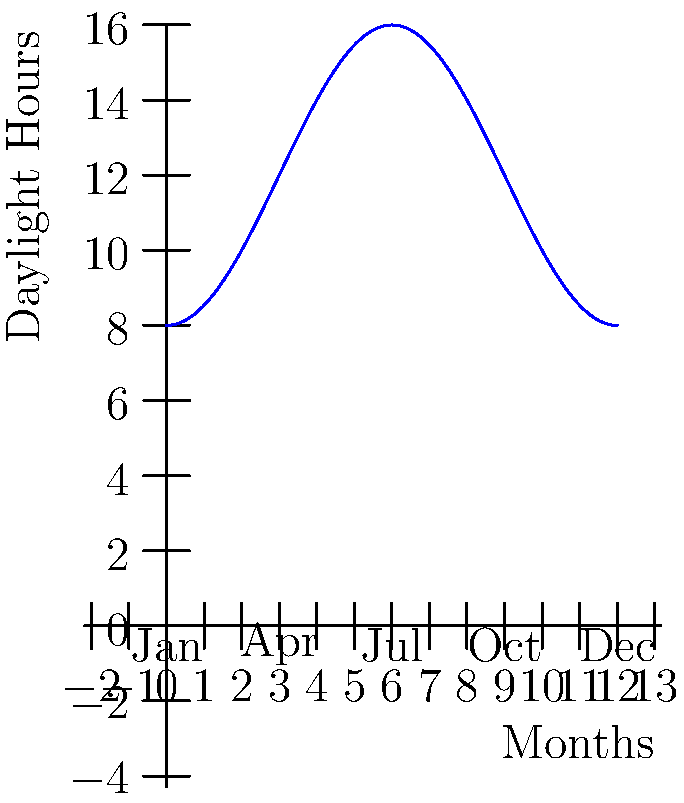The graph shows the average daylight hours throughout the year in Kuujjuaq, northern Quebec. During which month does the rate of change in daylight hours reach its maximum, and what is this maximum rate of change in hours per month? To find the month with the maximum rate of change in daylight hours and its value:

1. The rate of change is represented by the slope of the curve.
2. The steepest part of the curve occurs at the inflection points, where the curve changes from concave up to concave down or vice versa.
3. From the graph, we can see two inflection points: one between January and April, and another between September and December.
4. The steeper slope appears to be between September and December.
5. To calculate the rate of change:
   a. At September (x = 9), y ≈ 12 hours
   b. At December (x = 12), y ≈ 4 hours
6. Rate of change = $\frac{\Delta y}{\Delta x} = \frac{4 - 12}{12 - 9} = -\frac{8}{3}$ hours per month
7. The negative sign indicates decreasing daylight hours.
8. The maximum rate of change occurs in October, the middle month between September and December.

Therefore, the maximum rate of change occurs in October, with a value of approximately 2.67 hours per month decrease in daylight.
Answer: October, -2.67 hours/month 